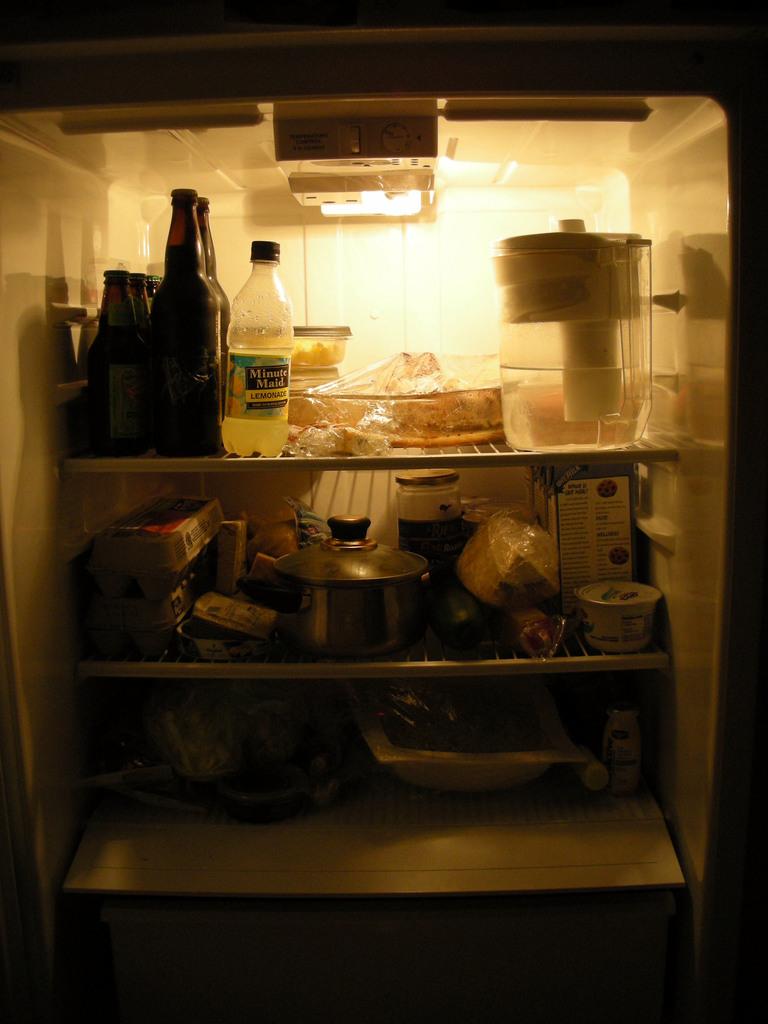What lemonade brand is at the top of the fridge?
Your answer should be very brief. Minute maid. Is the bottle with yellow liquid lemonade?
Make the answer very short. Yes. 